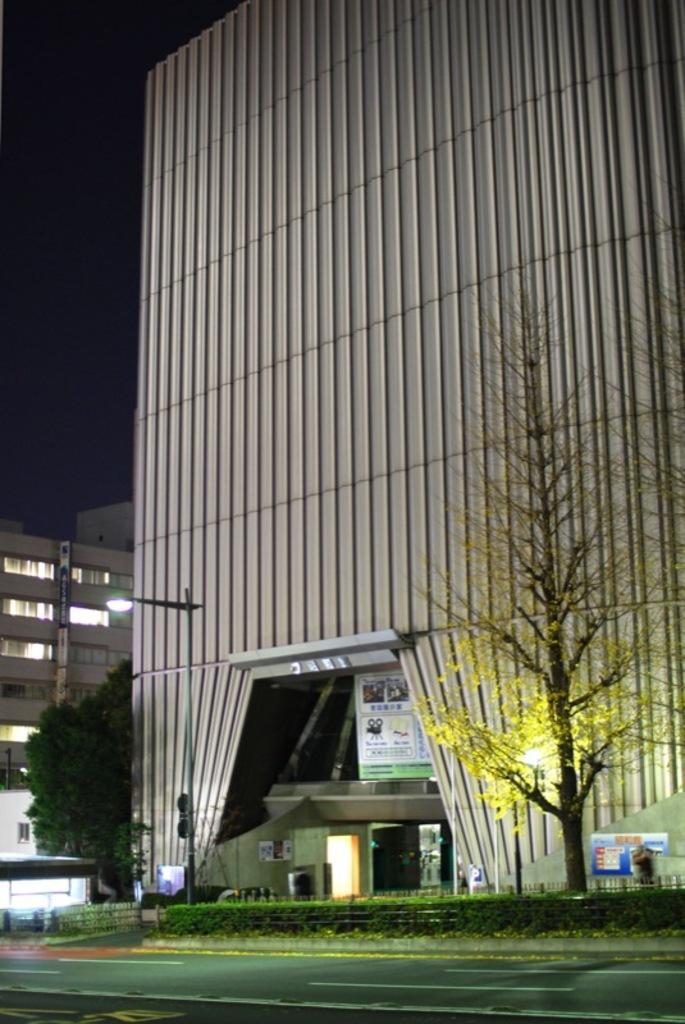How would you summarize this image in a sentence or two? In this image in the background there are some buildings and trees and pole and one street light, at the bottom there is road and grass and on the right side there is one board. On the top of the image there is sky. 